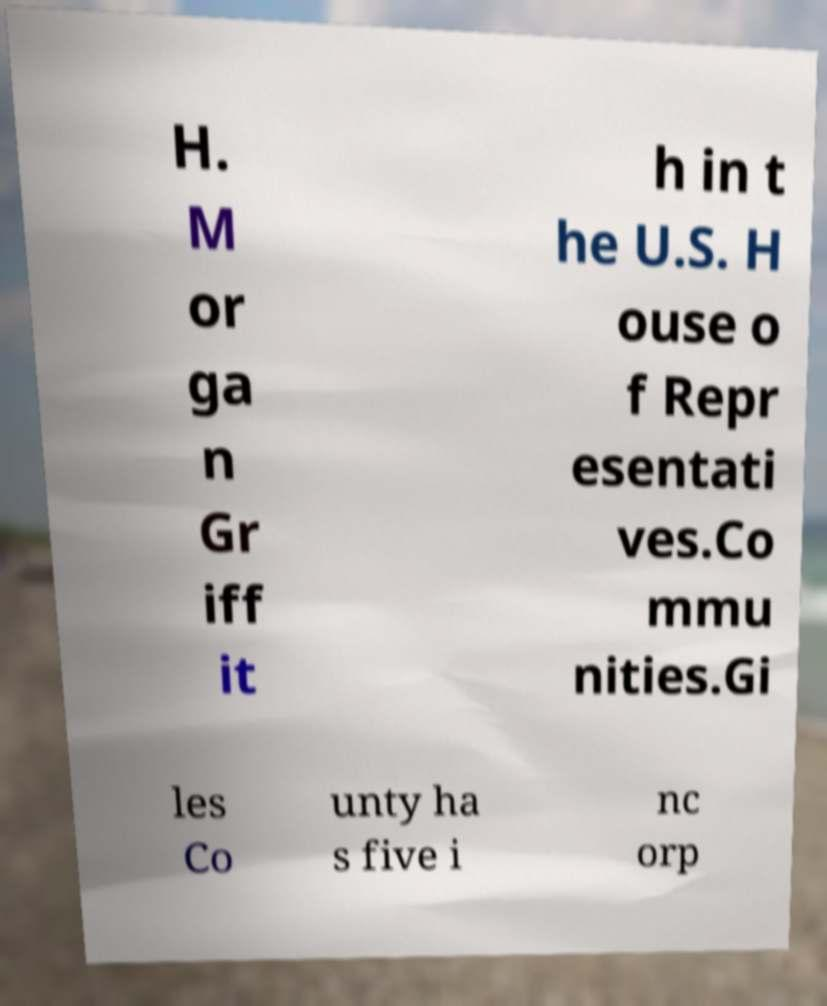What messages or text are displayed in this image? I need them in a readable, typed format. H. M or ga n Gr iff it h in t he U.S. H ouse o f Repr esentati ves.Co mmu nities.Gi les Co unty ha s five i nc orp 